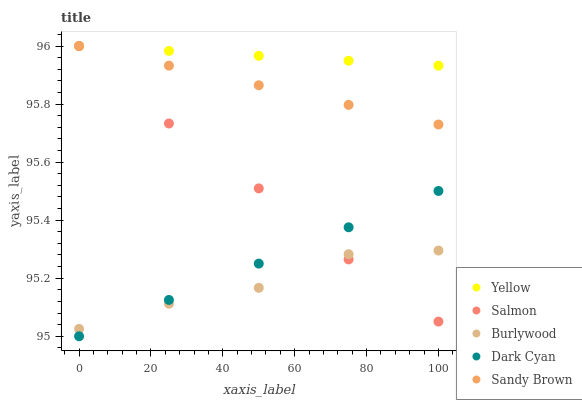Does Burlywood have the minimum area under the curve?
Answer yes or no. Yes. Does Yellow have the maximum area under the curve?
Answer yes or no. Yes. Does Dark Cyan have the minimum area under the curve?
Answer yes or no. No. Does Dark Cyan have the maximum area under the curve?
Answer yes or no. No. Is Dark Cyan the smoothest?
Answer yes or no. Yes. Is Burlywood the roughest?
Answer yes or no. Yes. Is Salmon the smoothest?
Answer yes or no. No. Is Salmon the roughest?
Answer yes or no. No. Does Dark Cyan have the lowest value?
Answer yes or no. Yes. Does Salmon have the lowest value?
Answer yes or no. No. Does Yellow have the highest value?
Answer yes or no. Yes. Does Dark Cyan have the highest value?
Answer yes or no. No. Is Dark Cyan less than Yellow?
Answer yes or no. Yes. Is Sandy Brown greater than Dark Cyan?
Answer yes or no. Yes. Does Burlywood intersect Salmon?
Answer yes or no. Yes. Is Burlywood less than Salmon?
Answer yes or no. No. Is Burlywood greater than Salmon?
Answer yes or no. No. Does Dark Cyan intersect Yellow?
Answer yes or no. No. 